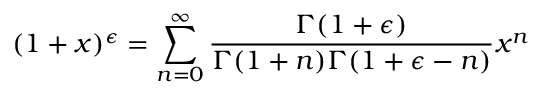Convert formula to latex. <formula><loc_0><loc_0><loc_500><loc_500>( 1 + x ) ^ { \epsilon } = \sum _ { n = 0 } ^ { \infty } \frac { \Gamma ( 1 + \epsilon ) } { \Gamma ( 1 + n ) \Gamma ( 1 + \epsilon - n ) } x ^ { n }</formula> 